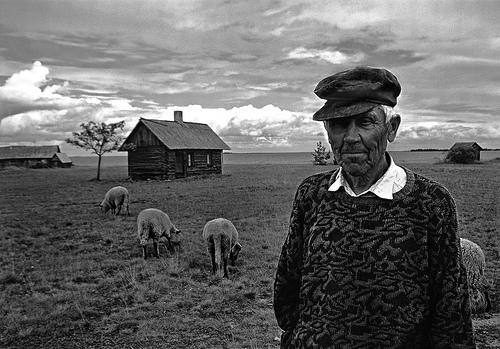What color is the shirt underneath of the old man's sweater? white 